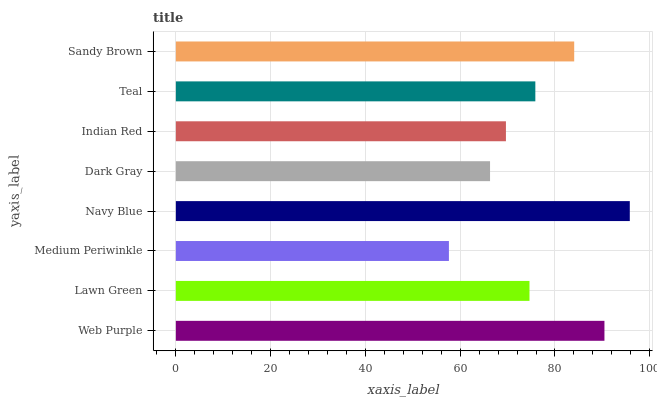Is Medium Periwinkle the minimum?
Answer yes or no. Yes. Is Navy Blue the maximum?
Answer yes or no. Yes. Is Lawn Green the minimum?
Answer yes or no. No. Is Lawn Green the maximum?
Answer yes or no. No. Is Web Purple greater than Lawn Green?
Answer yes or no. Yes. Is Lawn Green less than Web Purple?
Answer yes or no. Yes. Is Lawn Green greater than Web Purple?
Answer yes or no. No. Is Web Purple less than Lawn Green?
Answer yes or no. No. Is Teal the high median?
Answer yes or no. Yes. Is Lawn Green the low median?
Answer yes or no. Yes. Is Dark Gray the high median?
Answer yes or no. No. Is Dark Gray the low median?
Answer yes or no. No. 